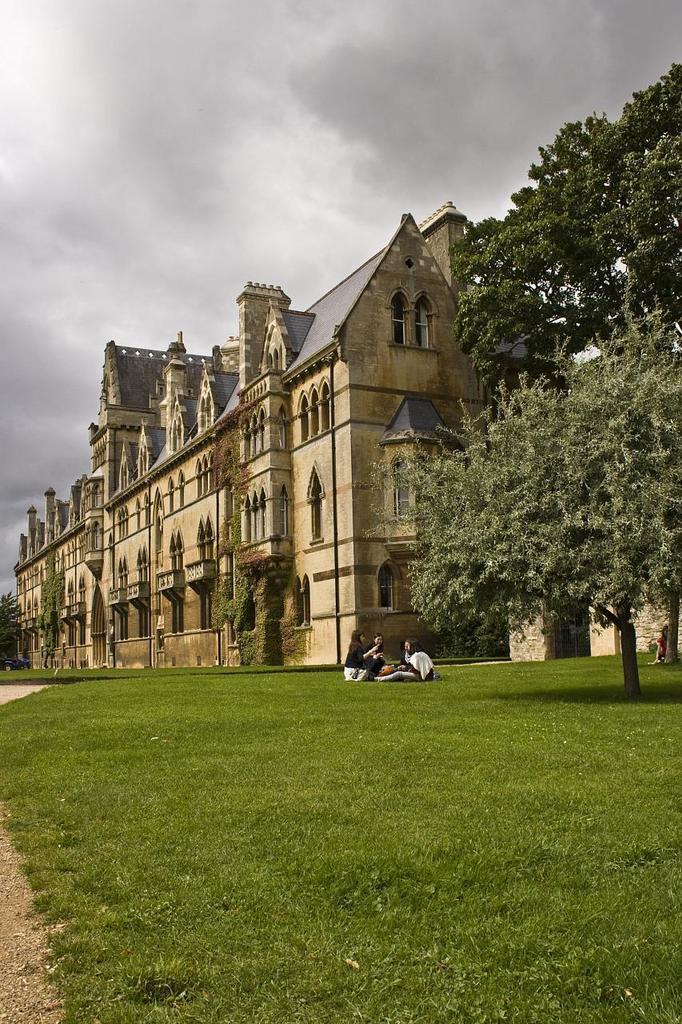In one or two sentences, can you explain what this image depicts? In this image I can see few people sitting on the grass and wearing the different color dresses. To the side I can see the big tree. To the side of the tree there is a building which is in brown color and I can see many windows to it. In the background I can see the cloudy sky. 